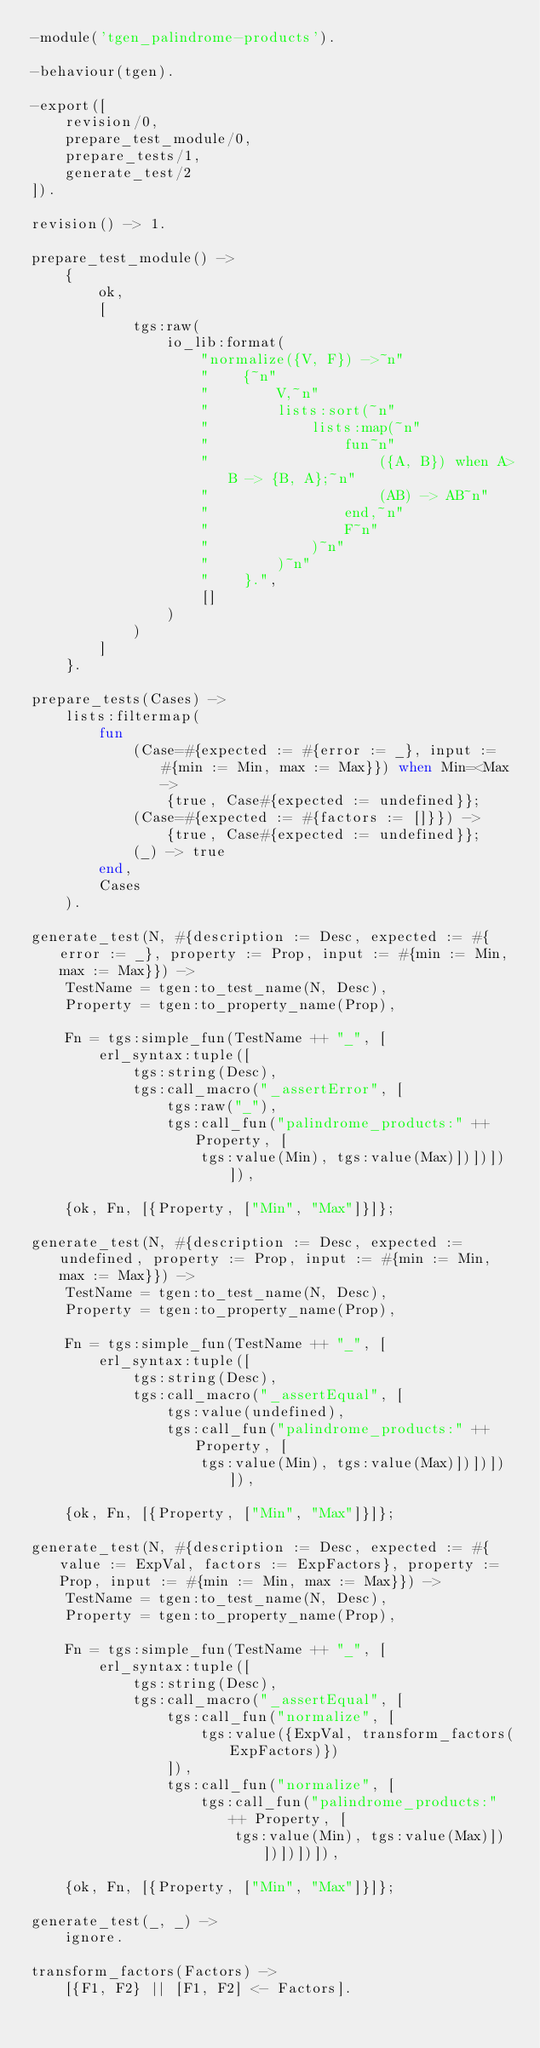<code> <loc_0><loc_0><loc_500><loc_500><_Erlang_>-module('tgen_palindrome-products').

-behaviour(tgen).

-export([
    revision/0,
    prepare_test_module/0,
    prepare_tests/1,
    generate_test/2
]).

revision() -> 1.

prepare_test_module() ->
    {
        ok,
        [
            tgs:raw(
                io_lib:format(
                    "normalize({V, F}) ->~n"
                    "    {~n"
                    "        V,~n"
                    "        lists:sort(~n"
                    "            lists:map(~n"
                    "                fun~n"
                    "                    ({A, B}) when A>B -> {B, A};~n"
                    "                    (AB) -> AB~n"
                    "                end,~n"
                    "                F~n"
                    "            )~n"
                    "        )~n"
                    "    }.",
                    []
                )
            )
        ]
    }.

prepare_tests(Cases) ->
    lists:filtermap(
        fun
            (Case=#{expected := #{error := _}, input := #{min := Min, max := Max}}) when Min=<Max ->
                {true, Case#{expected := undefined}};
            (Case=#{expected := #{factors := []}}) ->
                {true, Case#{expected := undefined}};
            (_) -> true
        end,
        Cases
    ).

generate_test(N, #{description := Desc, expected := #{error := _}, property := Prop, input := #{min := Min, max := Max}}) ->
    TestName = tgen:to_test_name(N, Desc),
    Property = tgen:to_property_name(Prop),

    Fn = tgs:simple_fun(TestName ++ "_", [
        erl_syntax:tuple([
            tgs:string(Desc),
            tgs:call_macro("_assertError", [
                tgs:raw("_"),
                tgs:call_fun("palindrome_products:" ++ Property, [
                    tgs:value(Min), tgs:value(Max)])])])]),

    {ok, Fn, [{Property, ["Min", "Max"]}]};

generate_test(N, #{description := Desc, expected := undefined, property := Prop, input := #{min := Min, max := Max}}) ->
    TestName = tgen:to_test_name(N, Desc),
    Property = tgen:to_property_name(Prop),

    Fn = tgs:simple_fun(TestName ++ "_", [
        erl_syntax:tuple([
            tgs:string(Desc),
            tgs:call_macro("_assertEqual", [
                tgs:value(undefined),
                tgs:call_fun("palindrome_products:" ++ Property, [
                    tgs:value(Min), tgs:value(Max)])])])]),

    {ok, Fn, [{Property, ["Min", "Max"]}]};

generate_test(N, #{description := Desc, expected := #{value := ExpVal, factors := ExpFactors}, property := Prop, input := #{min := Min, max := Max}}) ->
    TestName = tgen:to_test_name(N, Desc),
    Property = tgen:to_property_name(Prop),

    Fn = tgs:simple_fun(TestName ++ "_", [
        erl_syntax:tuple([
            tgs:string(Desc),
            tgs:call_macro("_assertEqual", [
                tgs:call_fun("normalize", [
                    tgs:value({ExpVal, transform_factors(ExpFactors)})
                ]),
                tgs:call_fun("normalize", [
                    tgs:call_fun("palindrome_products:" ++ Property, [
                        tgs:value(Min), tgs:value(Max)])])])])]),

    {ok, Fn, [{Property, ["Min", "Max"]}]};

generate_test(_, _) ->
    ignore.

transform_factors(Factors) ->
    [{F1, F2} || [F1, F2] <- Factors].
</code> 